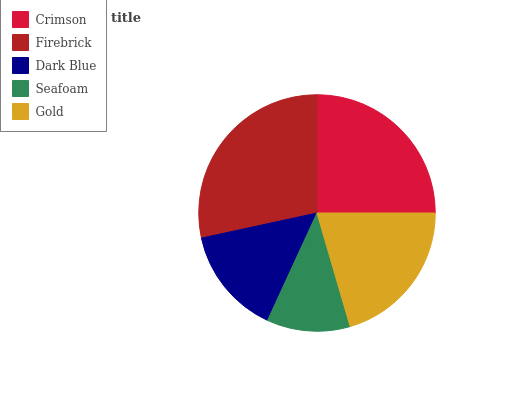Is Seafoam the minimum?
Answer yes or no. Yes. Is Firebrick the maximum?
Answer yes or no. Yes. Is Dark Blue the minimum?
Answer yes or no. No. Is Dark Blue the maximum?
Answer yes or no. No. Is Firebrick greater than Dark Blue?
Answer yes or no. Yes. Is Dark Blue less than Firebrick?
Answer yes or no. Yes. Is Dark Blue greater than Firebrick?
Answer yes or no. No. Is Firebrick less than Dark Blue?
Answer yes or no. No. Is Gold the high median?
Answer yes or no. Yes. Is Gold the low median?
Answer yes or no. Yes. Is Firebrick the high median?
Answer yes or no. No. Is Crimson the low median?
Answer yes or no. No. 